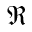Convert formula to latex. <formula><loc_0><loc_0><loc_500><loc_500>\Re</formula> 